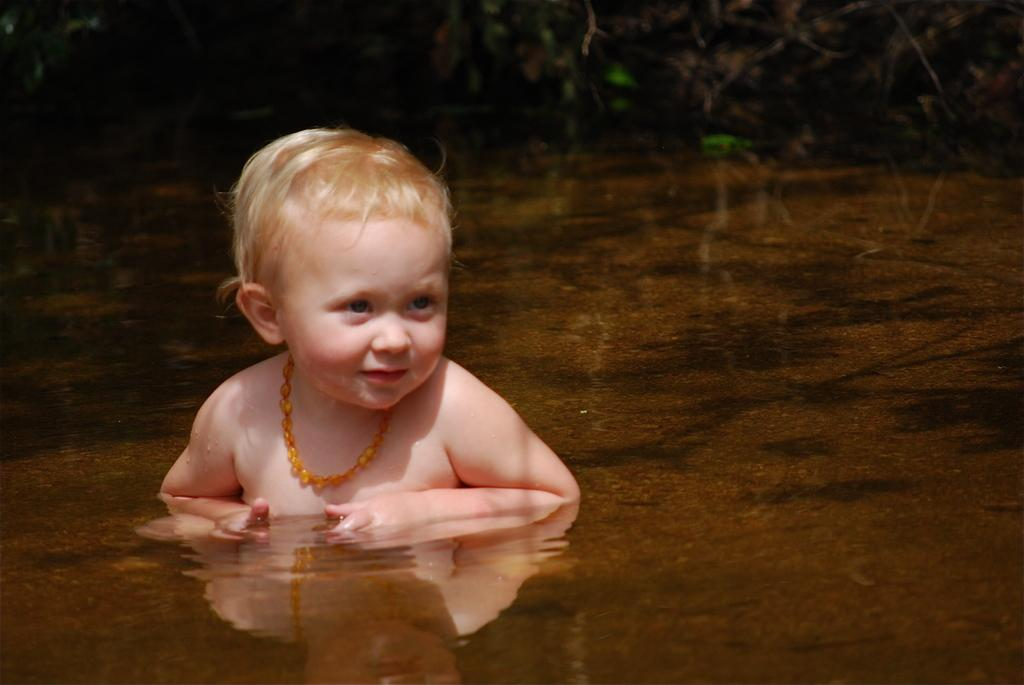What is the person in the image doing? The person is in the water. What can be seen in the background of the image? There are plants in the background of the image. What is the color of the plants? The plants are green in color. What type of throat medicine is the person taking in the image? There is no indication in the image that the person is taking any throat medicine. 